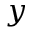Convert formula to latex. <formula><loc_0><loc_0><loc_500><loc_500>y</formula> 